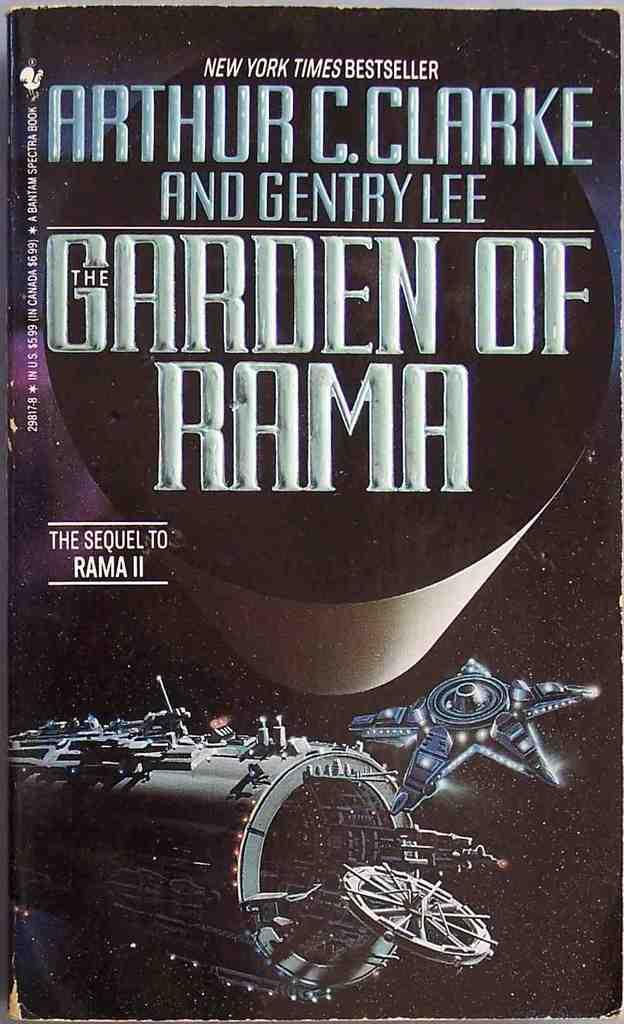<image>
Create a compact narrative representing the image presented. Garden of Rama book cover with an air ship featured. 